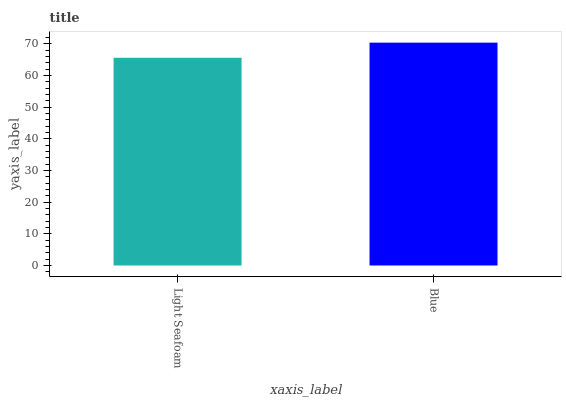Is Light Seafoam the minimum?
Answer yes or no. Yes. Is Blue the maximum?
Answer yes or no. Yes. Is Blue the minimum?
Answer yes or no. No. Is Blue greater than Light Seafoam?
Answer yes or no. Yes. Is Light Seafoam less than Blue?
Answer yes or no. Yes. Is Light Seafoam greater than Blue?
Answer yes or no. No. Is Blue less than Light Seafoam?
Answer yes or no. No. Is Blue the high median?
Answer yes or no. Yes. Is Light Seafoam the low median?
Answer yes or no. Yes. Is Light Seafoam the high median?
Answer yes or no. No. Is Blue the low median?
Answer yes or no. No. 